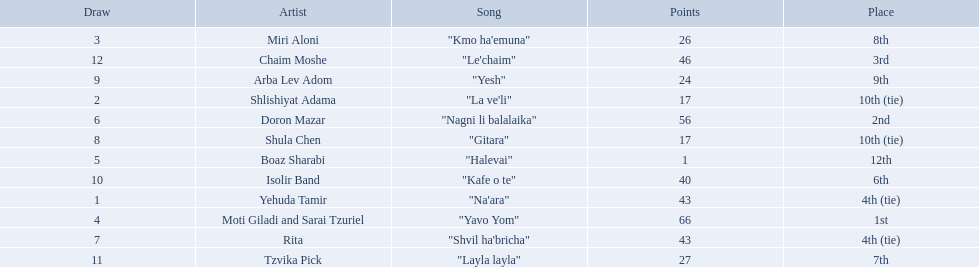What are the points in the competition? 43, 17, 26, 66, 1, 56, 43, 17, 24, 40, 27, 46. What is the lowest points? 1. What artist received these points? Boaz Sharabi. Can you parse all the data within this table? {'header': ['Draw', 'Artist', 'Song', 'Points', 'Place'], 'rows': [['3', 'Miri Aloni', '"Kmo ha\'emuna"', '26', '8th'], ['12', 'Chaim Moshe', '"Le\'chaim"', '46', '3rd'], ['9', 'Arba Lev Adom', '"Yesh"', '24', '9th'], ['2', 'Shlishiyat Adama', '"La ve\'li"', '17', '10th (tie)'], ['6', 'Doron Mazar', '"Nagni li balalaika"', '56', '2nd'], ['8', 'Shula Chen', '"Gitara"', '17', '10th (tie)'], ['5', 'Boaz Sharabi', '"Halevai"', '1', '12th'], ['10', 'Isolir Band', '"Kafe o te"', '40', '6th'], ['1', 'Yehuda Tamir', '"Na\'ara"', '43', '4th (tie)'], ['4', 'Moti Giladi and Sarai Tzuriel', '"Yavo Yom"', '66', '1st'], ['7', 'Rita', '"Shvil ha\'bricha"', '43', '4th (tie)'], ['11', 'Tzvika Pick', '"Layla layla"', '27', '7th']]} What is the place of the contestant who received only 1 point? 12th. What is the name of the artist listed in the previous question? Boaz Sharabi. 